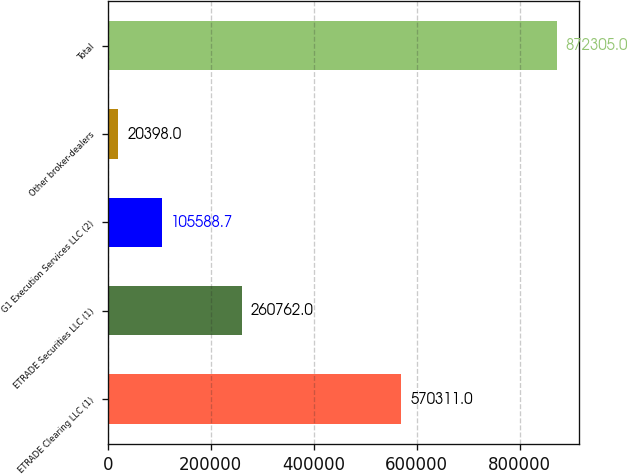Convert chart. <chart><loc_0><loc_0><loc_500><loc_500><bar_chart><fcel>ETRADE Clearing LLC (1)<fcel>ETRADE Securities LLC (1)<fcel>G1 Execution Services LLC (2)<fcel>Other broker-dealers<fcel>Total<nl><fcel>570311<fcel>260762<fcel>105589<fcel>20398<fcel>872305<nl></chart> 